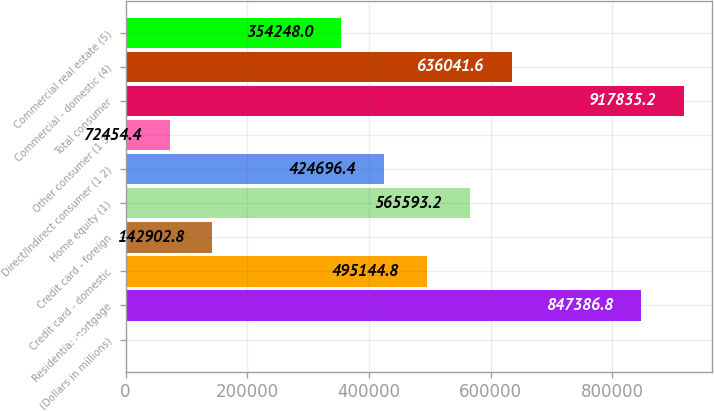Convert chart. <chart><loc_0><loc_0><loc_500><loc_500><bar_chart><fcel>(Dollars in millions)<fcel>Residential mortgage<fcel>Credit card - domestic<fcel>Credit card - foreign<fcel>Home equity (1)<fcel>Direct/Indirect consumer (1 2)<fcel>Other consumer (1 3)<fcel>Total consumer<fcel>Commercial - domestic (4)<fcel>Commercial real estate (5)<nl><fcel>2006<fcel>847387<fcel>495145<fcel>142903<fcel>565593<fcel>424696<fcel>72454.4<fcel>917835<fcel>636042<fcel>354248<nl></chart> 